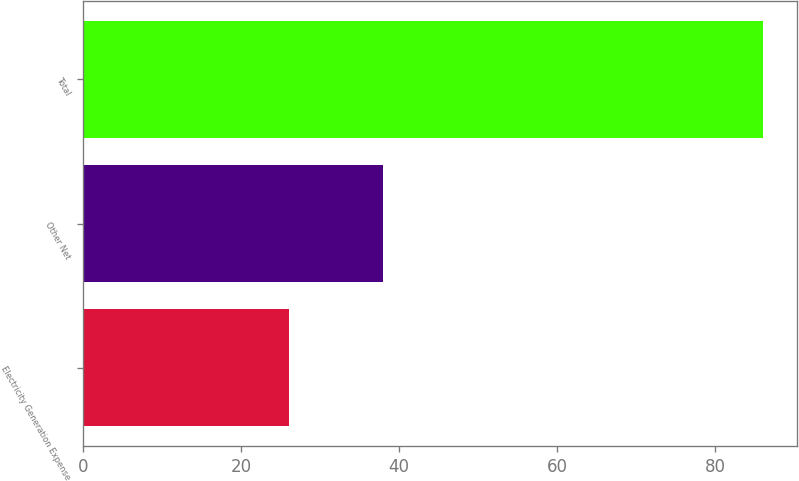Convert chart to OTSL. <chart><loc_0><loc_0><loc_500><loc_500><bar_chart><fcel>Electricity Generation Expense<fcel>Other Net<fcel>Total<nl><fcel>26<fcel>38<fcel>86<nl></chart> 